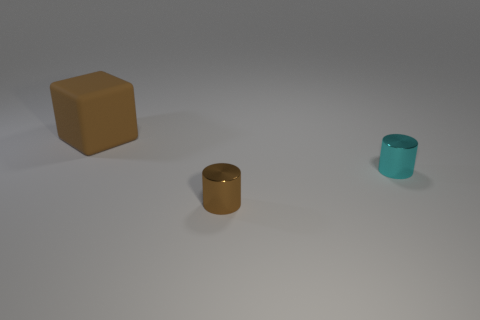Add 1 small cylinders. How many objects exist? 4 Subtract all cylinders. How many objects are left? 1 Subtract all brown cylinders. How many cylinders are left? 1 Subtract all small cyan metal things. Subtract all small brown objects. How many objects are left? 1 Add 1 small brown metal objects. How many small brown metal objects are left? 2 Add 3 blue shiny things. How many blue shiny things exist? 3 Subtract 0 green cylinders. How many objects are left? 3 Subtract all green cylinders. Subtract all yellow balls. How many cylinders are left? 2 Subtract all gray cubes. How many brown cylinders are left? 1 